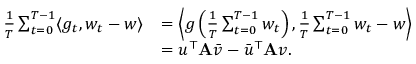Convert formula to latex. <formula><loc_0><loc_0><loc_500><loc_500>\begin{array} { r l } { \frac { 1 } { T } \sum _ { t = 0 } ^ { T - 1 } \langle g _ { t } , w _ { t } - w \rangle } & { = \left \langle g \left ( \frac { 1 } { T } \sum _ { t = 0 } ^ { T - 1 } w _ { t } \right ) , \frac { 1 } { T } \sum _ { t = 0 } ^ { T - 1 } w _ { t } - w \right \rangle } \\ & { = u ^ { \top } A \bar { v } - \bar { u } ^ { \top } A v . } \end{array}</formula> 